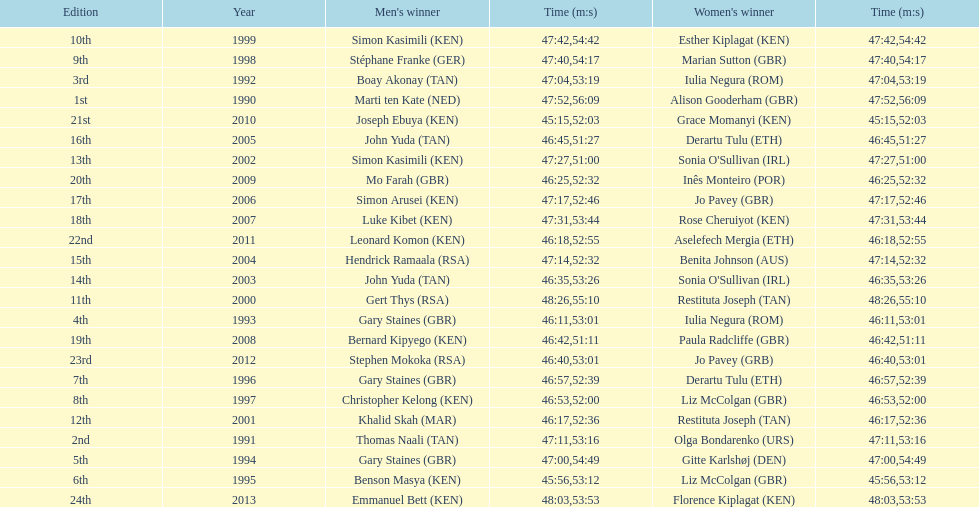How long did sonia o'sullivan take to finish in 2003? 53:26. 